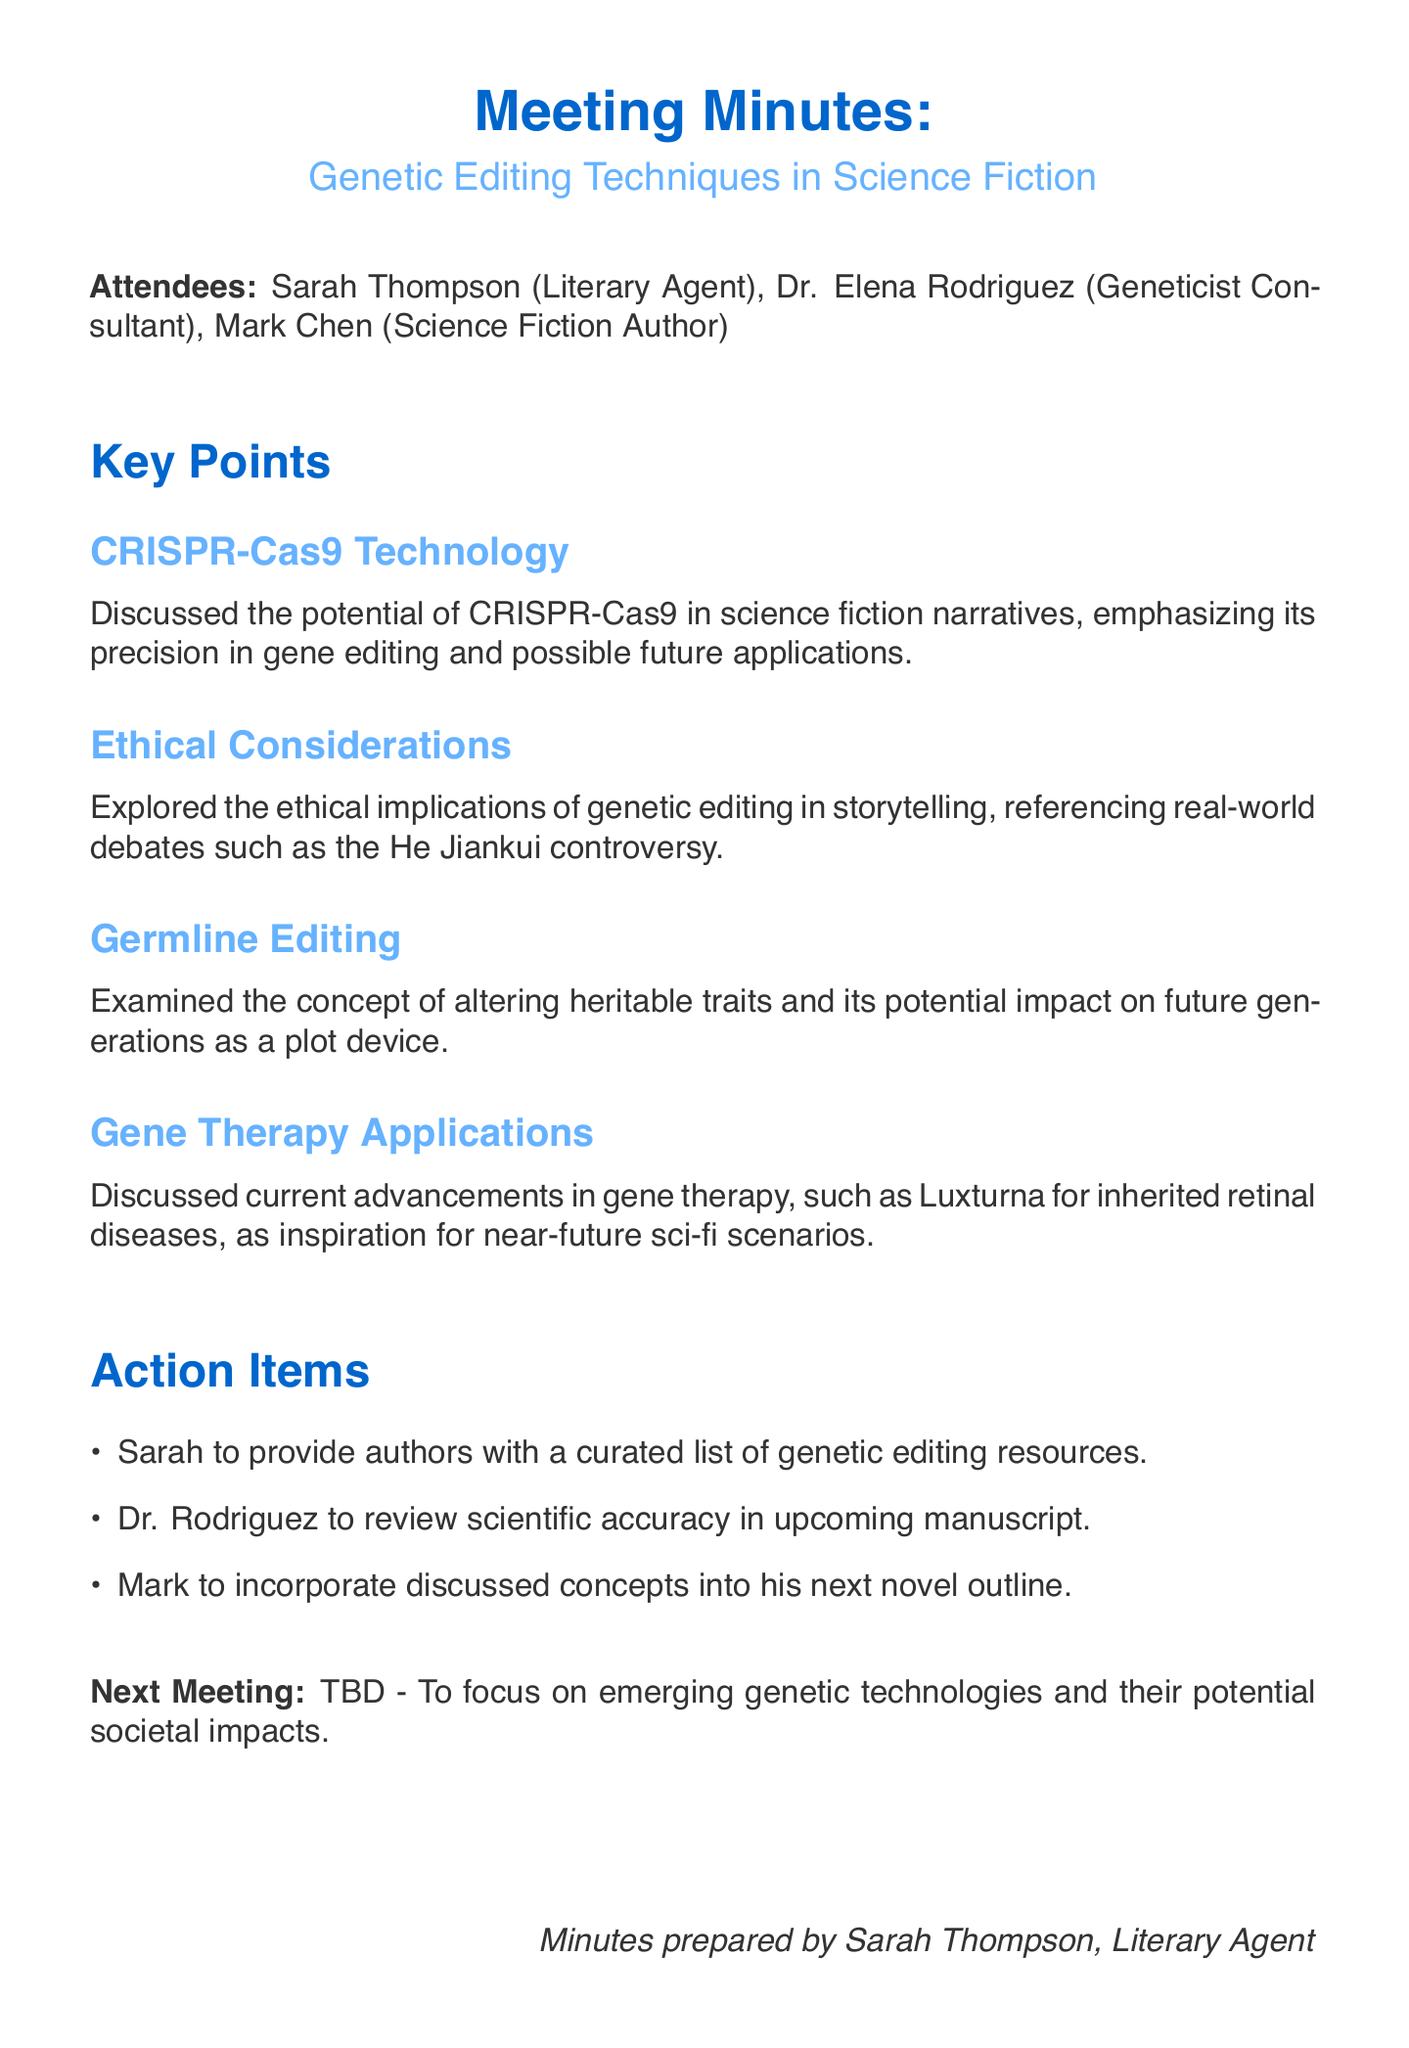What is the meeting topic? The main focus of the meeting is identified in the document as the discussion of genetic editing techniques.
Answer: Genetic Editing Techniques in Science Fiction Who is the geneticist consultant? The document lists Dr. Elena Rodriguez as the consultant with expertise in genetics.
Answer: Dr. Elena Rodriguez What technology was emphasized for its precision in gene editing? The key point discusses the capabilities of a specific gene editing technology during the meeting.
Answer: CRISPR-Cas9 Technology What ethical controversy was referenced? The discussion included real-world debates highlighting a case related to genetic editing, which is specifically mentioned.
Answer: He Jiankui controversy What action item involves Sarah Thompson? The document identifies a specific task that Sarah Thompson is responsible for following the meeting.
Answer: Provide authors with a curated list of genetic editing resources What is one application of gene therapy discussed? The minutes mention a specific gene therapy advancement as an example relevant to near-future scenarios in science fiction.
Answer: Luxturna for inherited retinal diseases What aspect of genetic editing was considered as a plot device? The discussions included examining the implications of altering certain traits, which is suggested for storytelling.
Answer: Germline Editing When is the next meeting planned? The document states that the date for the next meeting is to be determined, focusing on a specific topic.
Answer: TBD Who prepared these minutes? The document includes a note identifying the individual responsible for drafting the meeting minutes.
Answer: Sarah Thompson 